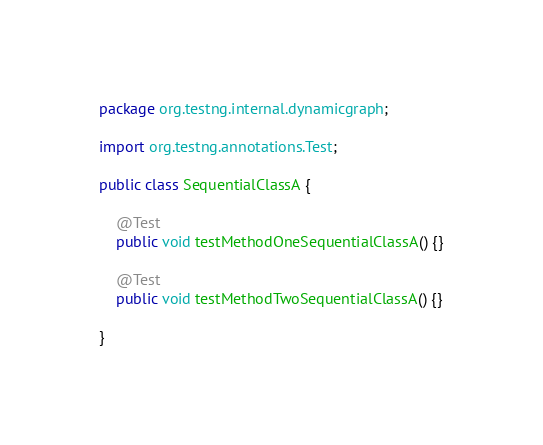<code> <loc_0><loc_0><loc_500><loc_500><_Java_>package org.testng.internal.dynamicgraph;

import org.testng.annotations.Test;

public class SequentialClassA {

    @Test
    public void testMethodOneSequentialClassA() {}

    @Test
    public void testMethodTwoSequentialClassA() {}

}
</code> 